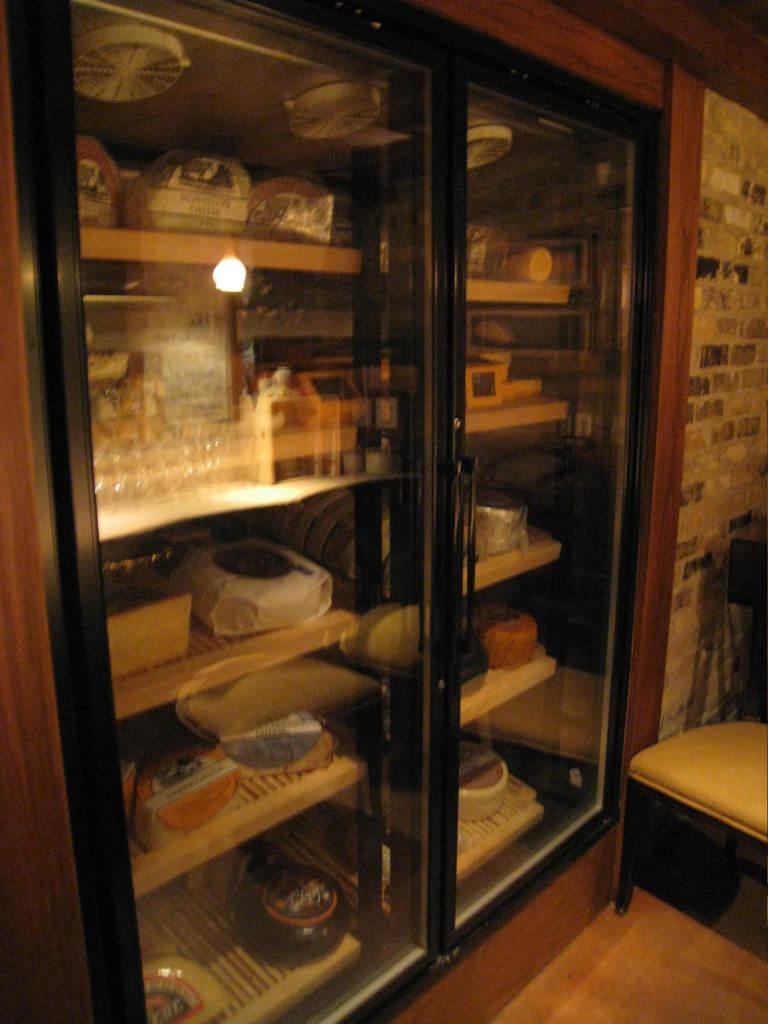Where is the chair located in the image? The chair is in the bottom right hand corner of the image. What is in the middle of the image? There is a door in the middle of the image. What type of space does the image depict? The image depicts a room with many items inside. Can you see any fields in the image? There are no fields present in the image; it depicts a room with a door and a chair. What type of plant is on the table in the image? There is no plant on the table in the image; it only shows a chair and a door. 